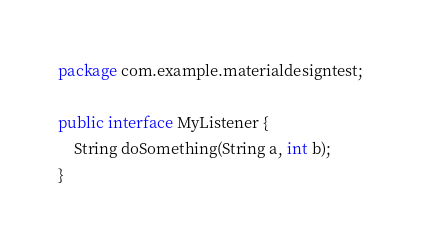<code> <loc_0><loc_0><loc_500><loc_500><_Java_>package com.example.materialdesigntest;

public interface MyListener {
    String doSomething(String a, int b);
}
</code> 